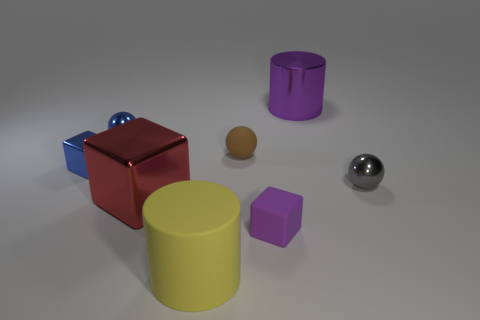Subtract 1 spheres. How many spheres are left? 2 Subtract all purple balls. Subtract all purple cylinders. How many balls are left? 3 Add 1 large purple cylinders. How many objects exist? 9 Subtract all balls. How many objects are left? 5 Add 7 yellow matte things. How many yellow matte things exist? 8 Subtract 0 gray cubes. How many objects are left? 8 Subtract all brown rubber cylinders. Subtract all tiny purple matte objects. How many objects are left? 7 Add 3 big metal objects. How many big metal objects are left? 5 